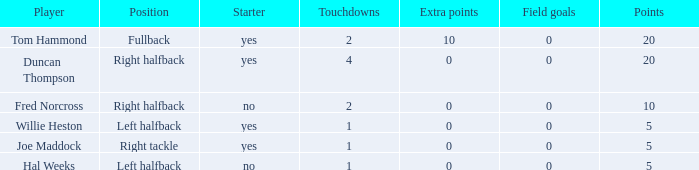How many times did duncan thompson successfully score field goals? 0.0. 